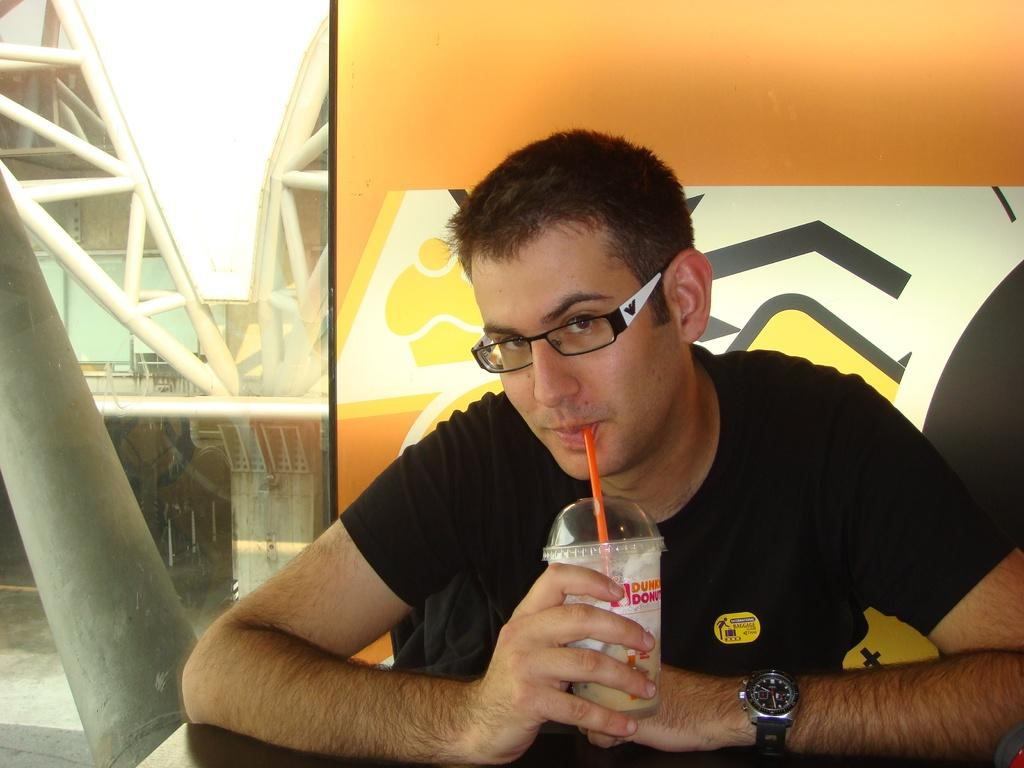What is the man in the image doing? The man is sitting in the image. What is the man holding in his hand? The man is holding a disposable tumbler in his hand. What can be seen in the background of the image? There is a wall in the background of the image. What type of sock is the man wearing in the image? There is no sock visible in the image, as the man is sitting and only his upper body is shown. 